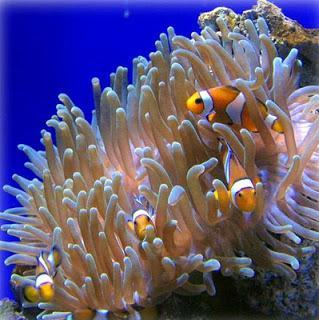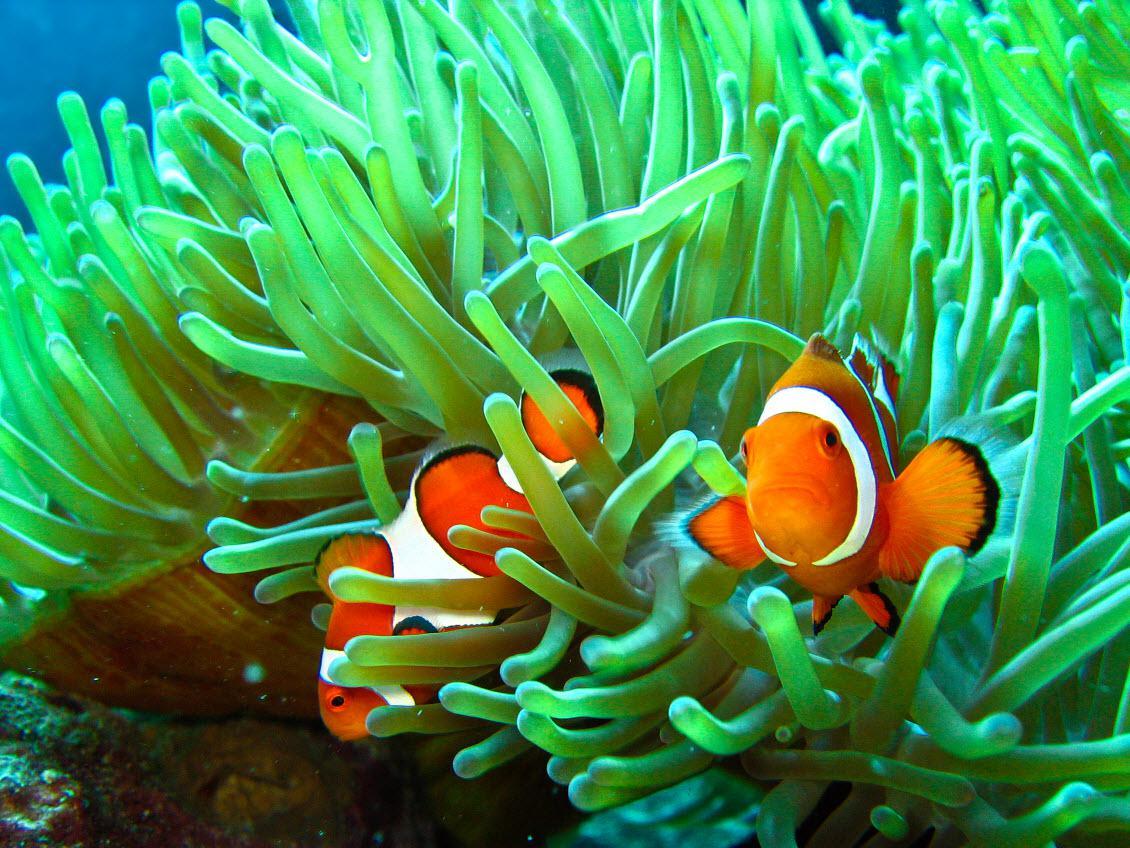The first image is the image on the left, the second image is the image on the right. Evaluate the accuracy of this statement regarding the images: "Exactly two clown fish swim through anemone tendrils in one image.". Is it true? Answer yes or no. Yes. 